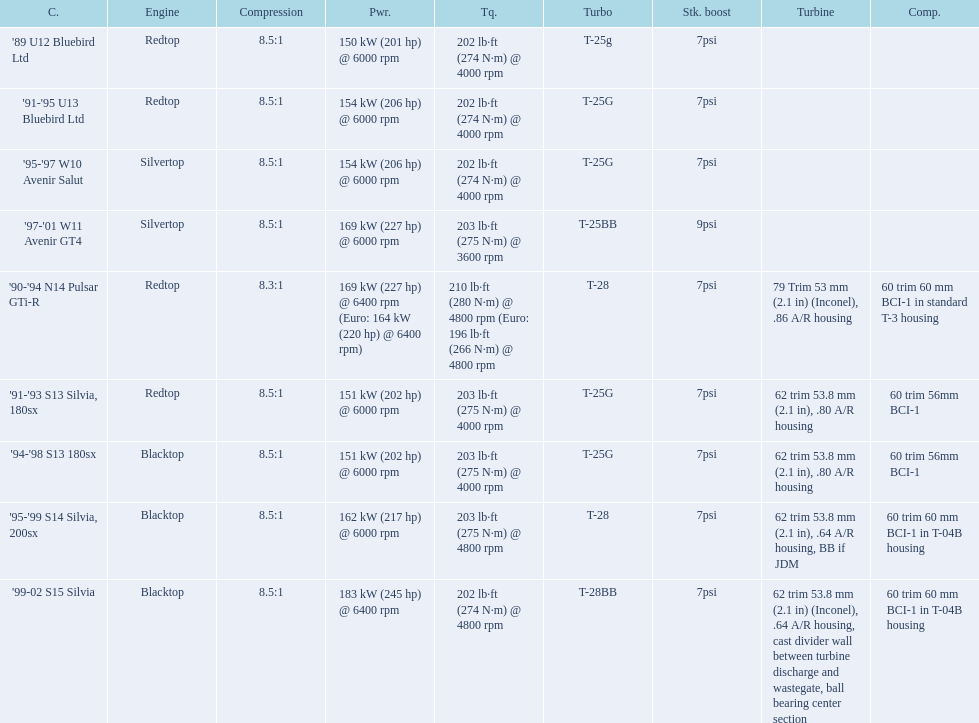What cars are there? '89 U12 Bluebird Ltd, 7psi, '91-'95 U13 Bluebird Ltd, 7psi, '95-'97 W10 Avenir Salut, 7psi, '97-'01 W11 Avenir GT4, 9psi, '90-'94 N14 Pulsar GTi-R, 7psi, '91-'93 S13 Silvia, 180sx, 7psi, '94-'98 S13 180sx, 7psi, '95-'99 S14 Silvia, 200sx, 7psi, '99-02 S15 Silvia, 7psi. Which stock boost is over 7psi? '97-'01 W11 Avenir GT4, 9psi. What car is it? '97-'01 W11 Avenir GT4. 